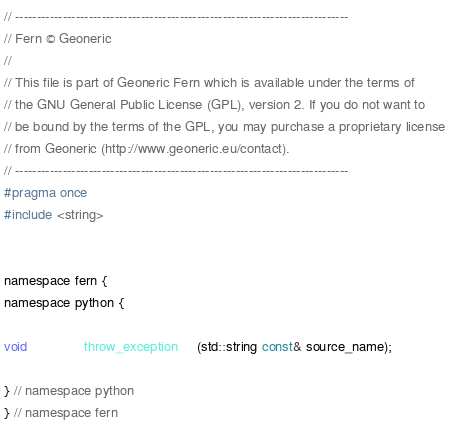Convert code to text. <code><loc_0><loc_0><loc_500><loc_500><_C_>// -----------------------------------------------------------------------------
// Fern © Geoneric
//
// This file is part of Geoneric Fern which is available under the terms of
// the GNU General Public License (GPL), version 2. If you do not want to
// be bound by the terms of the GPL, you may purchase a proprietary license
// from Geoneric (http://www.geoneric.eu/contact).
// -----------------------------------------------------------------------------
#pragma once
#include <string>


namespace fern {
namespace python {

void               throw_exception     (std::string const& source_name);

} // namespace python
} // namespace fern
</code> 